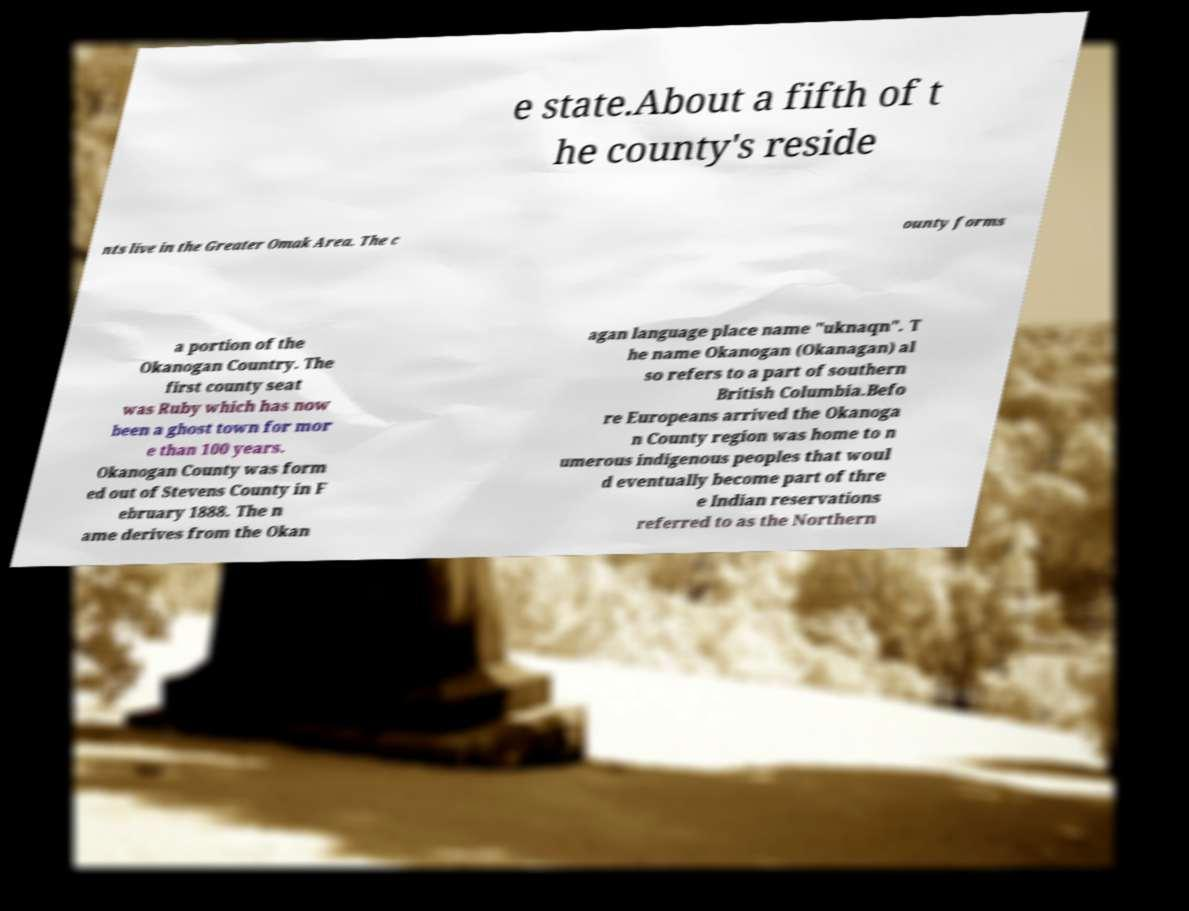For documentation purposes, I need the text within this image transcribed. Could you provide that? e state.About a fifth of t he county's reside nts live in the Greater Omak Area. The c ounty forms a portion of the Okanogan Country. The first county seat was Ruby which has now been a ghost town for mor e than 100 years. Okanogan County was form ed out of Stevens County in F ebruary 1888. The n ame derives from the Okan agan language place name "uknaqn". T he name Okanogan (Okanagan) al so refers to a part of southern British Columbia.Befo re Europeans arrived the Okanoga n County region was home to n umerous indigenous peoples that woul d eventually become part of thre e Indian reservations referred to as the Northern 